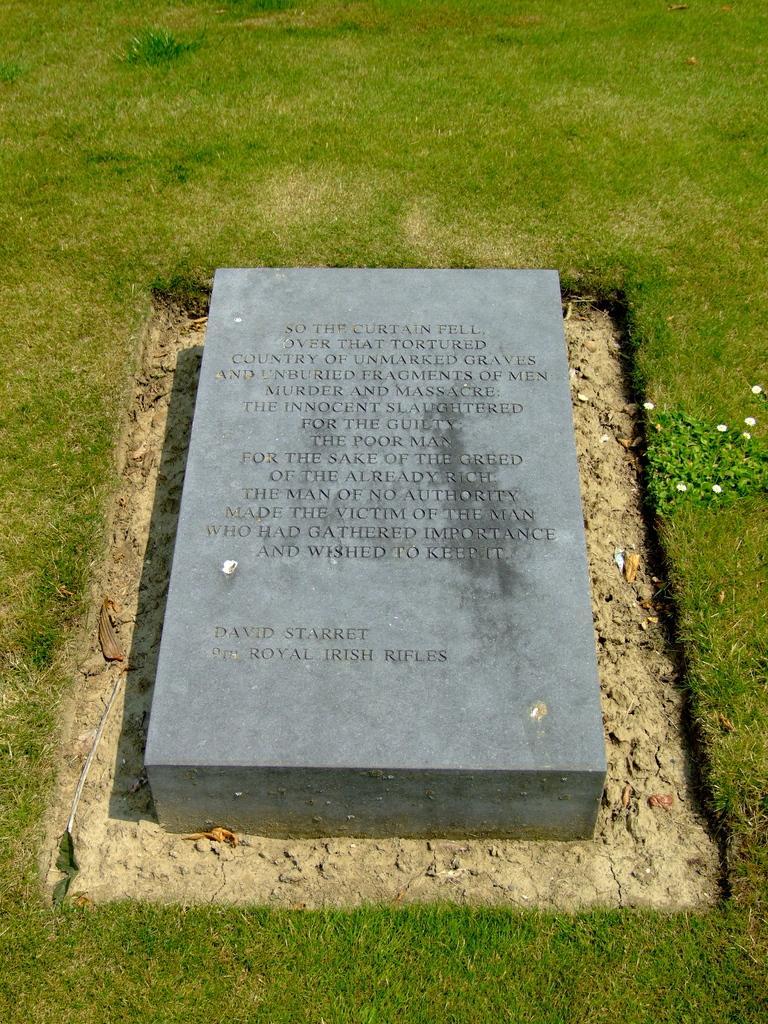Describe this image in one or two sentences. In this image we can see a grave with some text written on it and grassy land. 